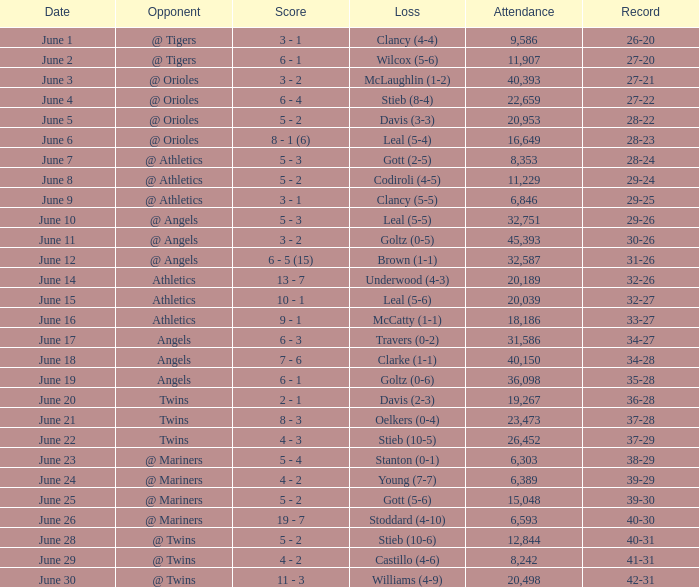What was the milestone for the date of june 14? 32-26. 